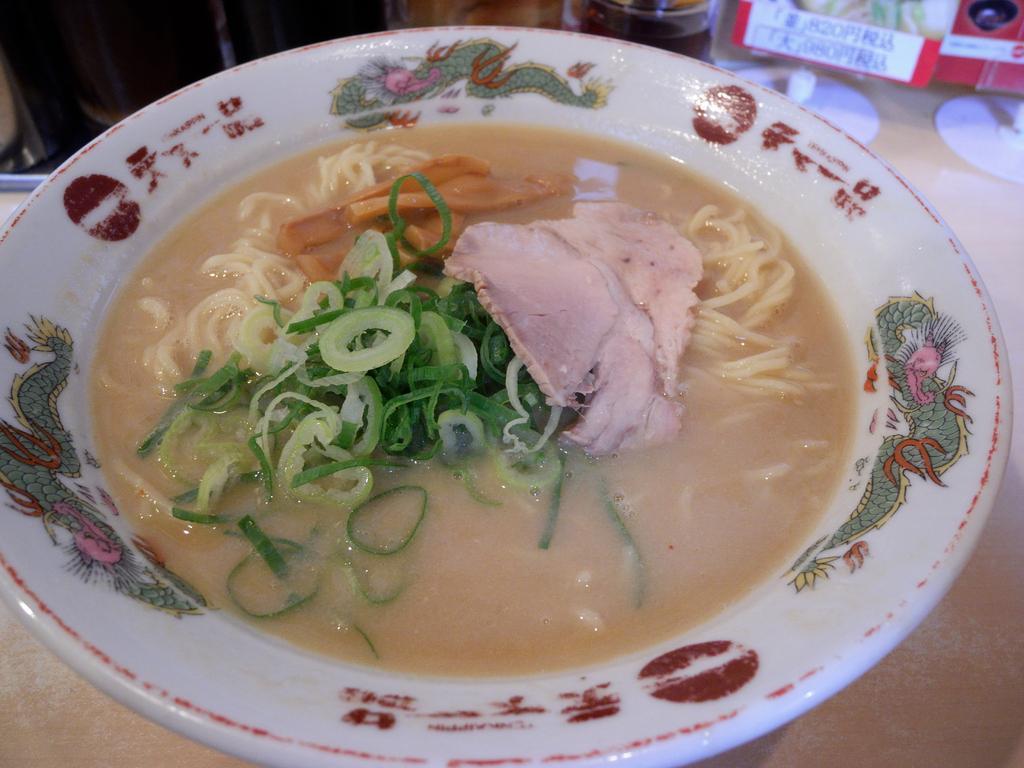In one or two sentences, can you explain what this image depicts? In this picture there is an edible and soup placed in a plate. 